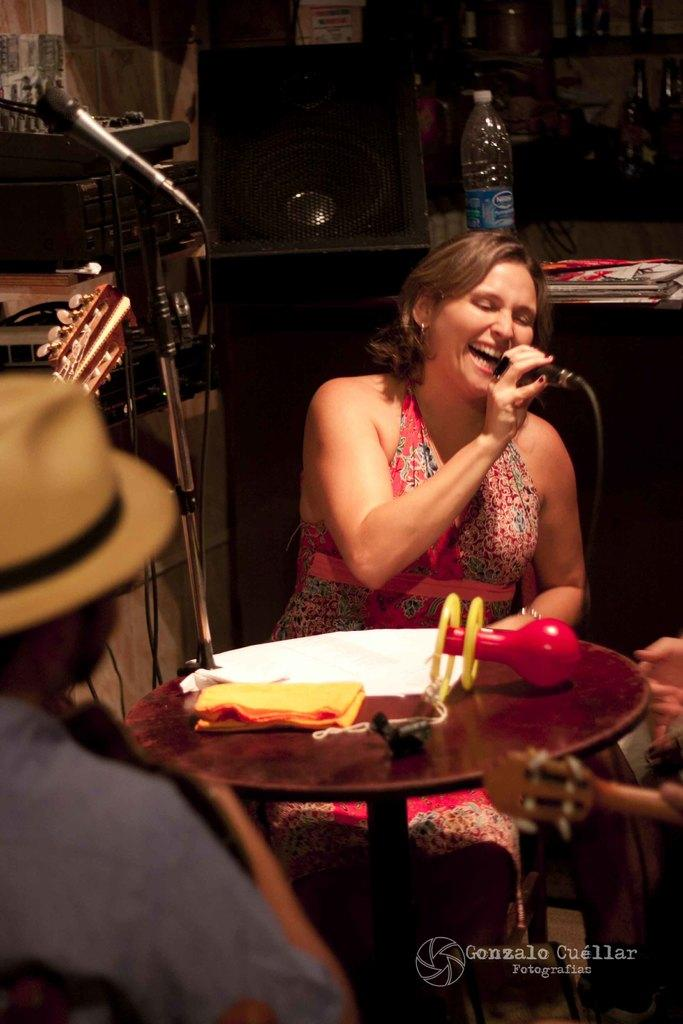Who is the main subject in the image? There is a lady in the image. What is the lady doing in the image? The lady is sitting in front of a table and singing into a microphone. How many people are present in the image? There are two persons in the image. What are the two persons doing in the image? The two persons are playing guitars. Can you tell me where the coach is parked in the image? There is no coach present in the image. What type of lake can be seen in the background of the image? There is no lake visible in the image. 